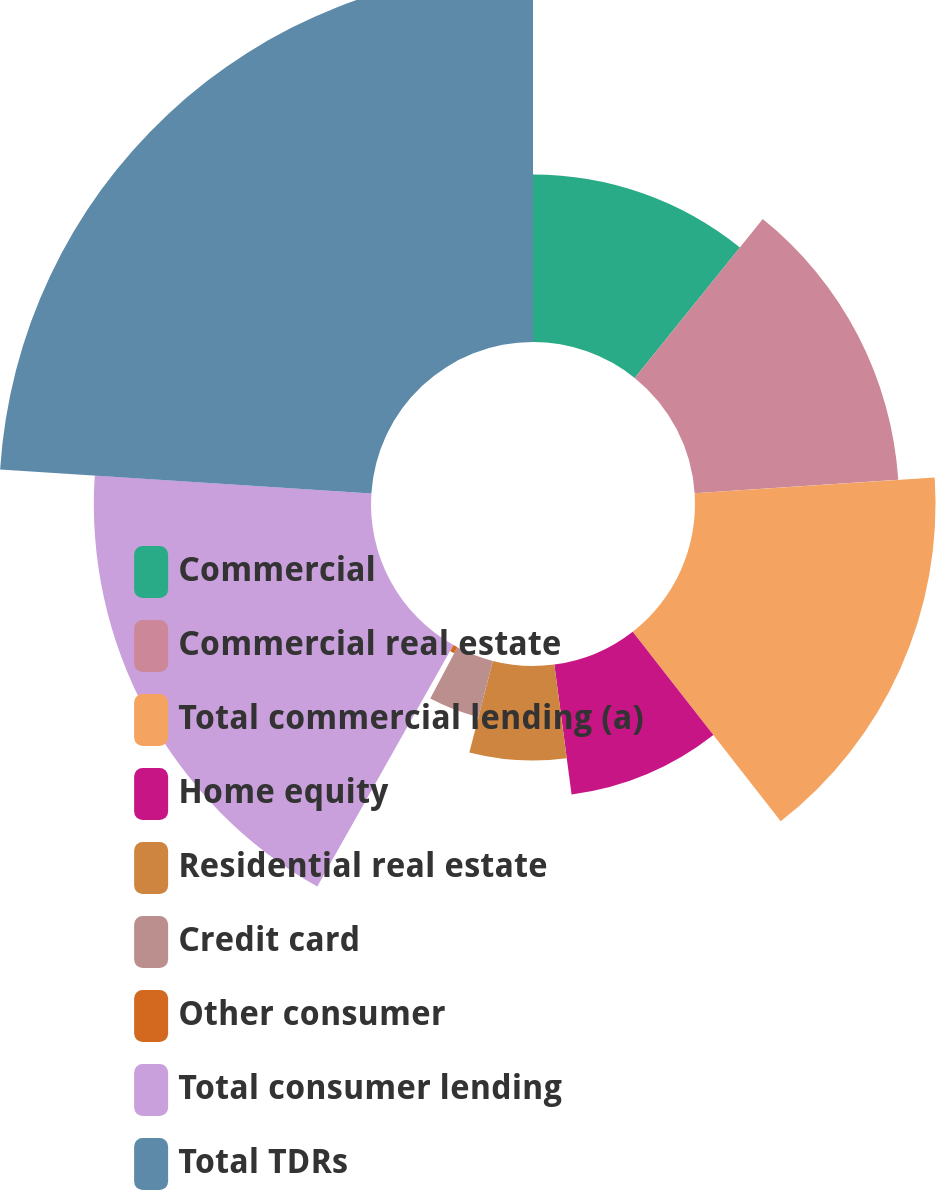Convert chart to OTSL. <chart><loc_0><loc_0><loc_500><loc_500><pie_chart><fcel>Commercial<fcel>Commercial real estate<fcel>Total commercial lending (a)<fcel>Home equity<fcel>Residential real estate<fcel>Credit card<fcel>Other consumer<fcel>Total consumer lending<fcel>Total TDRs<nl><fcel>10.8%<fcel>13.15%<fcel>15.5%<fcel>8.45%<fcel>6.09%<fcel>3.74%<fcel>0.44%<fcel>17.86%<fcel>23.97%<nl></chart> 